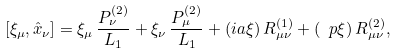<formula> <loc_0><loc_0><loc_500><loc_500>[ \xi _ { \mu } , \hat { x } _ { \nu } ] = \xi _ { \mu } \, \frac { P _ { \nu } ^ { ( 2 ) } } { L _ { 1 } } + \xi _ { \nu } \, \frac { P _ { \mu } ^ { ( 2 ) } } { L _ { 1 } } + ( i a \xi ) \, R ^ { ( 1 ) } _ { \mu \nu } + ( \ p \xi ) \, R ^ { ( 2 ) } _ { \mu \nu } ,</formula> 